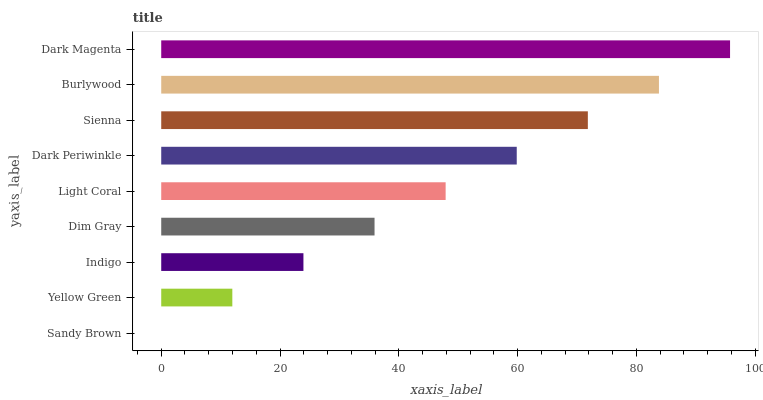Is Sandy Brown the minimum?
Answer yes or no. Yes. Is Dark Magenta the maximum?
Answer yes or no. Yes. Is Yellow Green the minimum?
Answer yes or no. No. Is Yellow Green the maximum?
Answer yes or no. No. Is Yellow Green greater than Sandy Brown?
Answer yes or no. Yes. Is Sandy Brown less than Yellow Green?
Answer yes or no. Yes. Is Sandy Brown greater than Yellow Green?
Answer yes or no. No. Is Yellow Green less than Sandy Brown?
Answer yes or no. No. Is Light Coral the high median?
Answer yes or no. Yes. Is Light Coral the low median?
Answer yes or no. Yes. Is Burlywood the high median?
Answer yes or no. No. Is Yellow Green the low median?
Answer yes or no. No. 